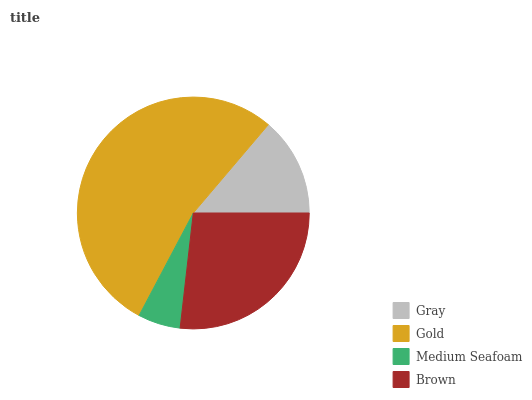Is Medium Seafoam the minimum?
Answer yes or no. Yes. Is Gold the maximum?
Answer yes or no. Yes. Is Gold the minimum?
Answer yes or no. No. Is Medium Seafoam the maximum?
Answer yes or no. No. Is Gold greater than Medium Seafoam?
Answer yes or no. Yes. Is Medium Seafoam less than Gold?
Answer yes or no. Yes. Is Medium Seafoam greater than Gold?
Answer yes or no. No. Is Gold less than Medium Seafoam?
Answer yes or no. No. Is Brown the high median?
Answer yes or no. Yes. Is Gray the low median?
Answer yes or no. Yes. Is Gold the high median?
Answer yes or no. No. Is Gold the low median?
Answer yes or no. No. 